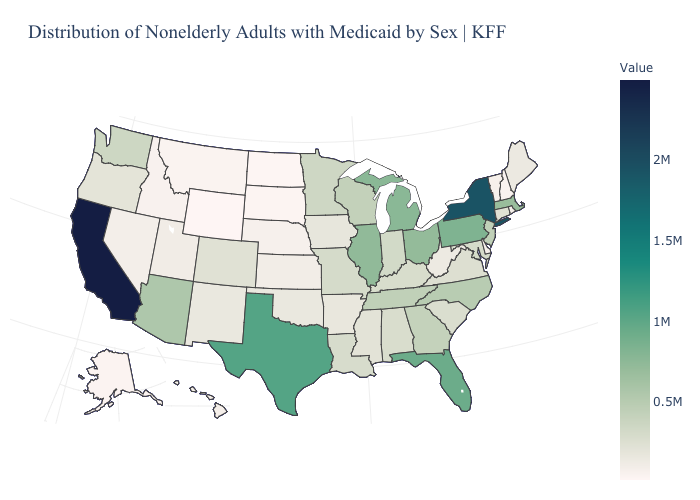Does Vermont have the lowest value in the Northeast?
Concise answer only. No. Which states have the lowest value in the USA?
Short answer required. Wyoming. Among the states that border Wisconsin , does Michigan have the highest value?
Keep it brief. Yes. Does Delaware have the lowest value in the South?
Write a very short answer. Yes. Which states have the lowest value in the USA?
Quick response, please. Wyoming. Among the states that border Delaware , does Pennsylvania have the lowest value?
Keep it brief. No. 